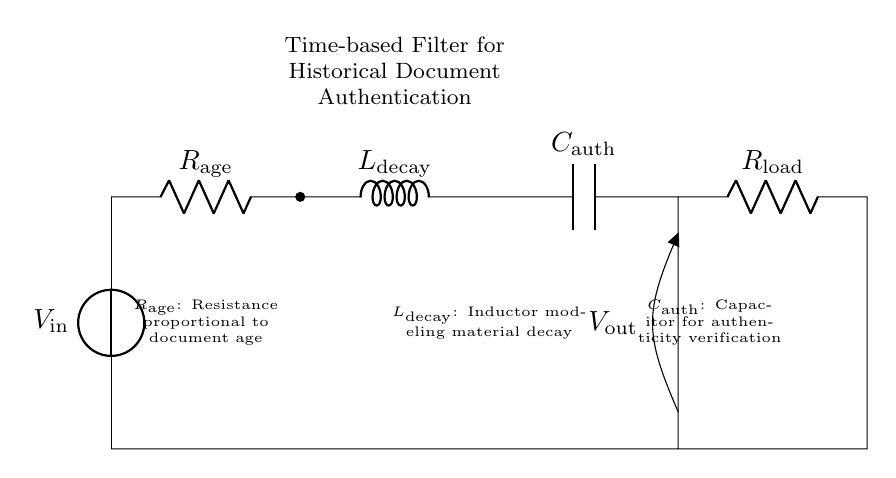What is the function of the resistor labeled R_age? The resistor R_age is connected in the circuit to represent resistance that is proportional to the document's age. It affects the time constant and performance of the filter.
Answer: Proportional to document age What component models material decay in the circuit? The component that models material decay is the inductor labeled L_decay. Inductors generally store energy in a magnetic field and can simulate the gradual degradation of material in an aging document.
Answer: Inductor What does the capacitor C_auth do in this circuit? The capacitor C_auth is used for authenticity verification, effectively responding to changes in the circuit to help filter and validate the authenticity of the historical document.
Answer: Authenticity verification Which component is responsible for the output voltage? The output voltage is indicated at the point where the circuit connects to the load resistor R_load, which influences the overall voltage based on the input and filtering characteristics.
Answer: Load resistor What is the relationship between R_age and the frequency response of the circuit? R_age alters the time constant of the RLC circuit, affecting how quickly the circuit responds to input signals, thus impacting the frequency response characteristics. A higher resistance generally lowers the response frequency.
Answer: Alters time constant What element impacts the circuit's decay response time? The decay response time in the circuit is primarily influenced by the inductor L_decay because it determines how quickly energy dissipates in the circuit when subjected to changes, reflecting the decay properties of historical materials.
Answer: Inductor 